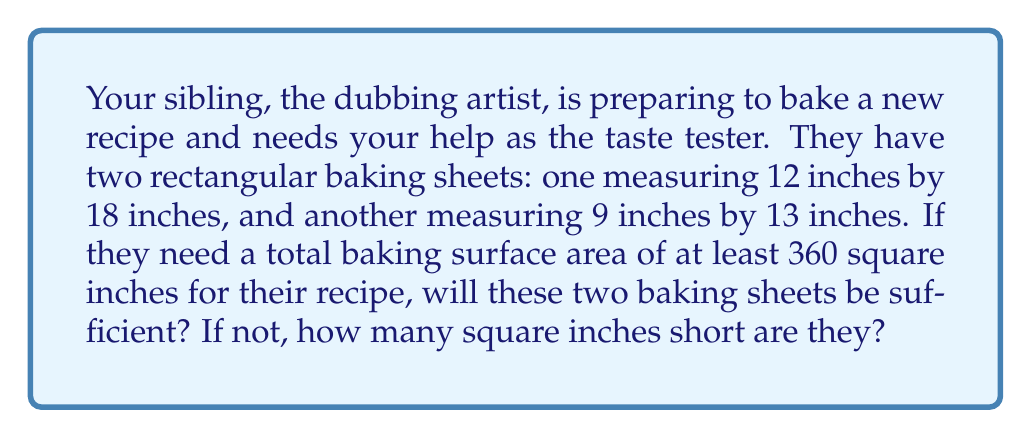Teach me how to tackle this problem. To solve this problem, we need to follow these steps:

1. Calculate the area of the first baking sheet:
   $A_1 = l_1 \times w_1 = 12 \text{ in} \times 18 \text{ in} = 216 \text{ sq in}$

2. Calculate the area of the second baking sheet:
   $A_2 = l_2 \times w_2 = 9 \text{ in} \times 13 \text{ in} = 117 \text{ sq in}$

3. Find the total area of both baking sheets:
   $A_{total} = A_1 + A_2 = 216 \text{ sq in} + 117 \text{ sq in} = 333 \text{ sq in}$

4. Compare the total area to the required area:
   Required area: 360 sq in
   Total available area: 333 sq in

5. Determine if the available area is sufficient:
   $333 \text{ sq in} < 360 \text{ sq in}$, so the available area is not sufficient.

6. Calculate the shortfall:
   Shortfall = Required area - Available area
   $= 360 \text{ sq in} - 333 \text{ sq in} = 27 \text{ sq in}$

Therefore, the two baking sheets are not sufficient, and they are 27 square inches short of the required area.
Answer: No, the two baking sheets are not sufficient. They are 27 square inches short of the required area. 